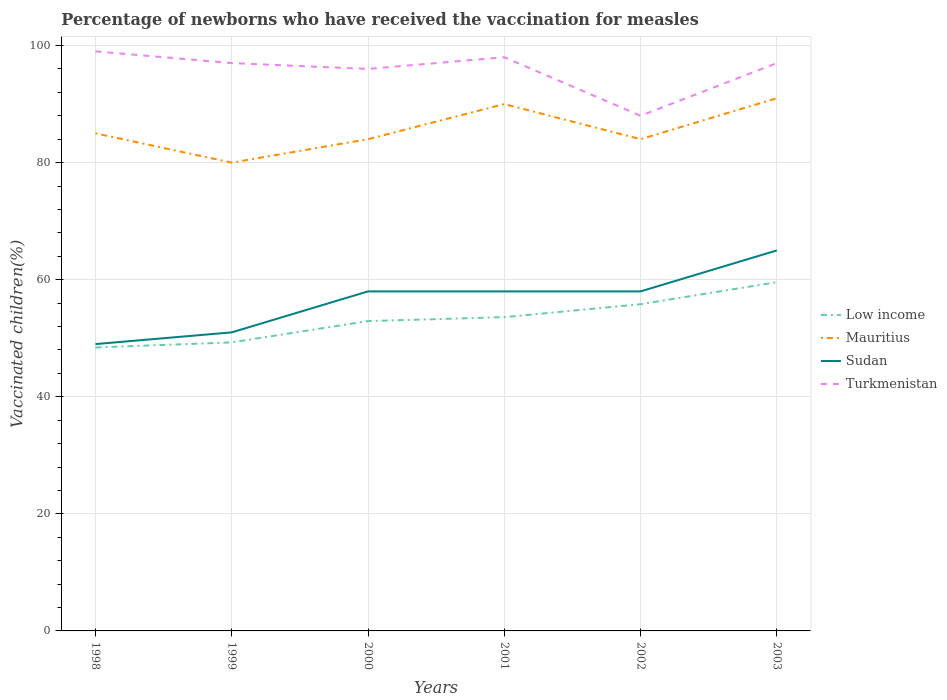Does the line corresponding to Low income intersect with the line corresponding to Mauritius?
Offer a terse response. No. Is the number of lines equal to the number of legend labels?
Provide a short and direct response. Yes. Across all years, what is the maximum percentage of vaccinated children in Sudan?
Give a very brief answer. 49. In which year was the percentage of vaccinated children in Mauritius maximum?
Your answer should be very brief. 1999. What is the difference between the highest and the lowest percentage of vaccinated children in Mauritius?
Keep it short and to the point. 2. Is the percentage of vaccinated children in Low income strictly greater than the percentage of vaccinated children in Mauritius over the years?
Make the answer very short. Yes. How many years are there in the graph?
Offer a very short reply. 6. Are the values on the major ticks of Y-axis written in scientific E-notation?
Ensure brevity in your answer.  No. Does the graph contain any zero values?
Provide a succinct answer. No. Does the graph contain grids?
Make the answer very short. Yes. What is the title of the graph?
Ensure brevity in your answer.  Percentage of newborns who have received the vaccination for measles. Does "Iran" appear as one of the legend labels in the graph?
Ensure brevity in your answer.  No. What is the label or title of the X-axis?
Ensure brevity in your answer.  Years. What is the label or title of the Y-axis?
Keep it short and to the point. Vaccinated children(%). What is the Vaccinated children(%) in Low income in 1998?
Ensure brevity in your answer.  48.42. What is the Vaccinated children(%) in Sudan in 1998?
Ensure brevity in your answer.  49. What is the Vaccinated children(%) in Turkmenistan in 1998?
Offer a terse response. 99. What is the Vaccinated children(%) of Low income in 1999?
Ensure brevity in your answer.  49.29. What is the Vaccinated children(%) of Sudan in 1999?
Offer a terse response. 51. What is the Vaccinated children(%) of Turkmenistan in 1999?
Keep it short and to the point. 97. What is the Vaccinated children(%) of Low income in 2000?
Offer a terse response. 52.93. What is the Vaccinated children(%) of Sudan in 2000?
Offer a terse response. 58. What is the Vaccinated children(%) in Turkmenistan in 2000?
Ensure brevity in your answer.  96. What is the Vaccinated children(%) in Low income in 2001?
Your answer should be very brief. 53.6. What is the Vaccinated children(%) in Mauritius in 2001?
Your answer should be compact. 90. What is the Vaccinated children(%) in Turkmenistan in 2001?
Your response must be concise. 98. What is the Vaccinated children(%) of Low income in 2002?
Your response must be concise. 55.81. What is the Vaccinated children(%) in Turkmenistan in 2002?
Make the answer very short. 88. What is the Vaccinated children(%) in Low income in 2003?
Provide a short and direct response. 59.57. What is the Vaccinated children(%) of Mauritius in 2003?
Offer a very short reply. 91. What is the Vaccinated children(%) in Sudan in 2003?
Your response must be concise. 65. What is the Vaccinated children(%) in Turkmenistan in 2003?
Your answer should be compact. 97. Across all years, what is the maximum Vaccinated children(%) of Low income?
Give a very brief answer. 59.57. Across all years, what is the maximum Vaccinated children(%) in Mauritius?
Ensure brevity in your answer.  91. Across all years, what is the maximum Vaccinated children(%) in Sudan?
Give a very brief answer. 65. Across all years, what is the minimum Vaccinated children(%) of Low income?
Your answer should be compact. 48.42. Across all years, what is the minimum Vaccinated children(%) in Sudan?
Make the answer very short. 49. What is the total Vaccinated children(%) in Low income in the graph?
Your response must be concise. 319.62. What is the total Vaccinated children(%) of Mauritius in the graph?
Your answer should be very brief. 514. What is the total Vaccinated children(%) of Sudan in the graph?
Provide a succinct answer. 339. What is the total Vaccinated children(%) of Turkmenistan in the graph?
Make the answer very short. 575. What is the difference between the Vaccinated children(%) of Low income in 1998 and that in 1999?
Make the answer very short. -0.87. What is the difference between the Vaccinated children(%) in Turkmenistan in 1998 and that in 1999?
Give a very brief answer. 2. What is the difference between the Vaccinated children(%) of Low income in 1998 and that in 2000?
Give a very brief answer. -4.51. What is the difference between the Vaccinated children(%) in Sudan in 1998 and that in 2000?
Your response must be concise. -9. What is the difference between the Vaccinated children(%) in Low income in 1998 and that in 2001?
Offer a very short reply. -5.18. What is the difference between the Vaccinated children(%) of Mauritius in 1998 and that in 2001?
Keep it short and to the point. -5. What is the difference between the Vaccinated children(%) in Sudan in 1998 and that in 2001?
Ensure brevity in your answer.  -9. What is the difference between the Vaccinated children(%) of Turkmenistan in 1998 and that in 2001?
Your answer should be compact. 1. What is the difference between the Vaccinated children(%) of Low income in 1998 and that in 2002?
Offer a terse response. -7.39. What is the difference between the Vaccinated children(%) in Sudan in 1998 and that in 2002?
Your answer should be compact. -9. What is the difference between the Vaccinated children(%) in Turkmenistan in 1998 and that in 2002?
Keep it short and to the point. 11. What is the difference between the Vaccinated children(%) of Low income in 1998 and that in 2003?
Give a very brief answer. -11.15. What is the difference between the Vaccinated children(%) of Sudan in 1998 and that in 2003?
Make the answer very short. -16. What is the difference between the Vaccinated children(%) of Low income in 1999 and that in 2000?
Keep it short and to the point. -3.63. What is the difference between the Vaccinated children(%) of Turkmenistan in 1999 and that in 2000?
Your answer should be very brief. 1. What is the difference between the Vaccinated children(%) in Low income in 1999 and that in 2001?
Your response must be concise. -4.31. What is the difference between the Vaccinated children(%) in Low income in 1999 and that in 2002?
Offer a very short reply. -6.52. What is the difference between the Vaccinated children(%) in Mauritius in 1999 and that in 2002?
Your answer should be very brief. -4. What is the difference between the Vaccinated children(%) of Turkmenistan in 1999 and that in 2002?
Your response must be concise. 9. What is the difference between the Vaccinated children(%) in Low income in 1999 and that in 2003?
Give a very brief answer. -10.28. What is the difference between the Vaccinated children(%) of Turkmenistan in 1999 and that in 2003?
Provide a short and direct response. 0. What is the difference between the Vaccinated children(%) of Low income in 2000 and that in 2001?
Offer a very short reply. -0.68. What is the difference between the Vaccinated children(%) in Mauritius in 2000 and that in 2001?
Make the answer very short. -6. What is the difference between the Vaccinated children(%) in Low income in 2000 and that in 2002?
Provide a succinct answer. -2.88. What is the difference between the Vaccinated children(%) of Mauritius in 2000 and that in 2002?
Keep it short and to the point. 0. What is the difference between the Vaccinated children(%) in Low income in 2000 and that in 2003?
Keep it short and to the point. -6.65. What is the difference between the Vaccinated children(%) in Sudan in 2000 and that in 2003?
Make the answer very short. -7. What is the difference between the Vaccinated children(%) of Low income in 2001 and that in 2002?
Your answer should be compact. -2.21. What is the difference between the Vaccinated children(%) of Mauritius in 2001 and that in 2002?
Offer a very short reply. 6. What is the difference between the Vaccinated children(%) of Turkmenistan in 2001 and that in 2002?
Offer a very short reply. 10. What is the difference between the Vaccinated children(%) in Low income in 2001 and that in 2003?
Make the answer very short. -5.97. What is the difference between the Vaccinated children(%) in Sudan in 2001 and that in 2003?
Give a very brief answer. -7. What is the difference between the Vaccinated children(%) of Turkmenistan in 2001 and that in 2003?
Provide a short and direct response. 1. What is the difference between the Vaccinated children(%) of Low income in 2002 and that in 2003?
Provide a short and direct response. -3.76. What is the difference between the Vaccinated children(%) in Mauritius in 2002 and that in 2003?
Keep it short and to the point. -7. What is the difference between the Vaccinated children(%) in Low income in 1998 and the Vaccinated children(%) in Mauritius in 1999?
Provide a short and direct response. -31.58. What is the difference between the Vaccinated children(%) of Low income in 1998 and the Vaccinated children(%) of Sudan in 1999?
Offer a very short reply. -2.58. What is the difference between the Vaccinated children(%) of Low income in 1998 and the Vaccinated children(%) of Turkmenistan in 1999?
Your answer should be very brief. -48.58. What is the difference between the Vaccinated children(%) in Mauritius in 1998 and the Vaccinated children(%) in Sudan in 1999?
Offer a terse response. 34. What is the difference between the Vaccinated children(%) in Mauritius in 1998 and the Vaccinated children(%) in Turkmenistan in 1999?
Provide a succinct answer. -12. What is the difference between the Vaccinated children(%) of Sudan in 1998 and the Vaccinated children(%) of Turkmenistan in 1999?
Offer a very short reply. -48. What is the difference between the Vaccinated children(%) in Low income in 1998 and the Vaccinated children(%) in Mauritius in 2000?
Offer a terse response. -35.58. What is the difference between the Vaccinated children(%) of Low income in 1998 and the Vaccinated children(%) of Sudan in 2000?
Your answer should be very brief. -9.58. What is the difference between the Vaccinated children(%) in Low income in 1998 and the Vaccinated children(%) in Turkmenistan in 2000?
Your answer should be compact. -47.58. What is the difference between the Vaccinated children(%) in Sudan in 1998 and the Vaccinated children(%) in Turkmenistan in 2000?
Ensure brevity in your answer.  -47. What is the difference between the Vaccinated children(%) of Low income in 1998 and the Vaccinated children(%) of Mauritius in 2001?
Ensure brevity in your answer.  -41.58. What is the difference between the Vaccinated children(%) of Low income in 1998 and the Vaccinated children(%) of Sudan in 2001?
Make the answer very short. -9.58. What is the difference between the Vaccinated children(%) in Low income in 1998 and the Vaccinated children(%) in Turkmenistan in 2001?
Your answer should be very brief. -49.58. What is the difference between the Vaccinated children(%) in Mauritius in 1998 and the Vaccinated children(%) in Turkmenistan in 2001?
Offer a very short reply. -13. What is the difference between the Vaccinated children(%) of Sudan in 1998 and the Vaccinated children(%) of Turkmenistan in 2001?
Your response must be concise. -49. What is the difference between the Vaccinated children(%) in Low income in 1998 and the Vaccinated children(%) in Mauritius in 2002?
Offer a terse response. -35.58. What is the difference between the Vaccinated children(%) in Low income in 1998 and the Vaccinated children(%) in Sudan in 2002?
Offer a very short reply. -9.58. What is the difference between the Vaccinated children(%) of Low income in 1998 and the Vaccinated children(%) of Turkmenistan in 2002?
Give a very brief answer. -39.58. What is the difference between the Vaccinated children(%) in Sudan in 1998 and the Vaccinated children(%) in Turkmenistan in 2002?
Your answer should be compact. -39. What is the difference between the Vaccinated children(%) in Low income in 1998 and the Vaccinated children(%) in Mauritius in 2003?
Your answer should be compact. -42.58. What is the difference between the Vaccinated children(%) of Low income in 1998 and the Vaccinated children(%) of Sudan in 2003?
Keep it short and to the point. -16.58. What is the difference between the Vaccinated children(%) in Low income in 1998 and the Vaccinated children(%) in Turkmenistan in 2003?
Provide a succinct answer. -48.58. What is the difference between the Vaccinated children(%) in Sudan in 1998 and the Vaccinated children(%) in Turkmenistan in 2003?
Your answer should be compact. -48. What is the difference between the Vaccinated children(%) of Low income in 1999 and the Vaccinated children(%) of Mauritius in 2000?
Offer a terse response. -34.71. What is the difference between the Vaccinated children(%) of Low income in 1999 and the Vaccinated children(%) of Sudan in 2000?
Give a very brief answer. -8.71. What is the difference between the Vaccinated children(%) in Low income in 1999 and the Vaccinated children(%) in Turkmenistan in 2000?
Ensure brevity in your answer.  -46.71. What is the difference between the Vaccinated children(%) of Mauritius in 1999 and the Vaccinated children(%) of Sudan in 2000?
Provide a short and direct response. 22. What is the difference between the Vaccinated children(%) in Mauritius in 1999 and the Vaccinated children(%) in Turkmenistan in 2000?
Give a very brief answer. -16. What is the difference between the Vaccinated children(%) of Sudan in 1999 and the Vaccinated children(%) of Turkmenistan in 2000?
Your answer should be very brief. -45. What is the difference between the Vaccinated children(%) of Low income in 1999 and the Vaccinated children(%) of Mauritius in 2001?
Ensure brevity in your answer.  -40.71. What is the difference between the Vaccinated children(%) in Low income in 1999 and the Vaccinated children(%) in Sudan in 2001?
Your answer should be very brief. -8.71. What is the difference between the Vaccinated children(%) in Low income in 1999 and the Vaccinated children(%) in Turkmenistan in 2001?
Ensure brevity in your answer.  -48.71. What is the difference between the Vaccinated children(%) in Sudan in 1999 and the Vaccinated children(%) in Turkmenistan in 2001?
Your answer should be very brief. -47. What is the difference between the Vaccinated children(%) of Low income in 1999 and the Vaccinated children(%) of Mauritius in 2002?
Make the answer very short. -34.71. What is the difference between the Vaccinated children(%) in Low income in 1999 and the Vaccinated children(%) in Sudan in 2002?
Give a very brief answer. -8.71. What is the difference between the Vaccinated children(%) in Low income in 1999 and the Vaccinated children(%) in Turkmenistan in 2002?
Provide a succinct answer. -38.71. What is the difference between the Vaccinated children(%) in Mauritius in 1999 and the Vaccinated children(%) in Sudan in 2002?
Your answer should be very brief. 22. What is the difference between the Vaccinated children(%) of Sudan in 1999 and the Vaccinated children(%) of Turkmenistan in 2002?
Offer a terse response. -37. What is the difference between the Vaccinated children(%) of Low income in 1999 and the Vaccinated children(%) of Mauritius in 2003?
Offer a terse response. -41.71. What is the difference between the Vaccinated children(%) in Low income in 1999 and the Vaccinated children(%) in Sudan in 2003?
Provide a succinct answer. -15.71. What is the difference between the Vaccinated children(%) of Low income in 1999 and the Vaccinated children(%) of Turkmenistan in 2003?
Provide a succinct answer. -47.71. What is the difference between the Vaccinated children(%) in Mauritius in 1999 and the Vaccinated children(%) in Turkmenistan in 2003?
Make the answer very short. -17. What is the difference between the Vaccinated children(%) of Sudan in 1999 and the Vaccinated children(%) of Turkmenistan in 2003?
Provide a short and direct response. -46. What is the difference between the Vaccinated children(%) in Low income in 2000 and the Vaccinated children(%) in Mauritius in 2001?
Give a very brief answer. -37.07. What is the difference between the Vaccinated children(%) of Low income in 2000 and the Vaccinated children(%) of Sudan in 2001?
Make the answer very short. -5.07. What is the difference between the Vaccinated children(%) of Low income in 2000 and the Vaccinated children(%) of Turkmenistan in 2001?
Offer a terse response. -45.07. What is the difference between the Vaccinated children(%) of Mauritius in 2000 and the Vaccinated children(%) of Sudan in 2001?
Your response must be concise. 26. What is the difference between the Vaccinated children(%) in Mauritius in 2000 and the Vaccinated children(%) in Turkmenistan in 2001?
Make the answer very short. -14. What is the difference between the Vaccinated children(%) of Low income in 2000 and the Vaccinated children(%) of Mauritius in 2002?
Offer a very short reply. -31.07. What is the difference between the Vaccinated children(%) in Low income in 2000 and the Vaccinated children(%) in Sudan in 2002?
Keep it short and to the point. -5.07. What is the difference between the Vaccinated children(%) of Low income in 2000 and the Vaccinated children(%) of Turkmenistan in 2002?
Ensure brevity in your answer.  -35.07. What is the difference between the Vaccinated children(%) of Mauritius in 2000 and the Vaccinated children(%) of Sudan in 2002?
Ensure brevity in your answer.  26. What is the difference between the Vaccinated children(%) in Low income in 2000 and the Vaccinated children(%) in Mauritius in 2003?
Provide a short and direct response. -38.07. What is the difference between the Vaccinated children(%) in Low income in 2000 and the Vaccinated children(%) in Sudan in 2003?
Provide a short and direct response. -12.07. What is the difference between the Vaccinated children(%) in Low income in 2000 and the Vaccinated children(%) in Turkmenistan in 2003?
Keep it short and to the point. -44.07. What is the difference between the Vaccinated children(%) of Mauritius in 2000 and the Vaccinated children(%) of Sudan in 2003?
Ensure brevity in your answer.  19. What is the difference between the Vaccinated children(%) in Sudan in 2000 and the Vaccinated children(%) in Turkmenistan in 2003?
Keep it short and to the point. -39. What is the difference between the Vaccinated children(%) in Low income in 2001 and the Vaccinated children(%) in Mauritius in 2002?
Keep it short and to the point. -30.4. What is the difference between the Vaccinated children(%) of Low income in 2001 and the Vaccinated children(%) of Sudan in 2002?
Offer a terse response. -4.4. What is the difference between the Vaccinated children(%) of Low income in 2001 and the Vaccinated children(%) of Turkmenistan in 2002?
Offer a very short reply. -34.4. What is the difference between the Vaccinated children(%) in Mauritius in 2001 and the Vaccinated children(%) in Turkmenistan in 2002?
Give a very brief answer. 2. What is the difference between the Vaccinated children(%) in Sudan in 2001 and the Vaccinated children(%) in Turkmenistan in 2002?
Keep it short and to the point. -30. What is the difference between the Vaccinated children(%) in Low income in 2001 and the Vaccinated children(%) in Mauritius in 2003?
Make the answer very short. -37.4. What is the difference between the Vaccinated children(%) in Low income in 2001 and the Vaccinated children(%) in Sudan in 2003?
Provide a short and direct response. -11.4. What is the difference between the Vaccinated children(%) in Low income in 2001 and the Vaccinated children(%) in Turkmenistan in 2003?
Your answer should be compact. -43.4. What is the difference between the Vaccinated children(%) of Mauritius in 2001 and the Vaccinated children(%) of Sudan in 2003?
Ensure brevity in your answer.  25. What is the difference between the Vaccinated children(%) of Sudan in 2001 and the Vaccinated children(%) of Turkmenistan in 2003?
Make the answer very short. -39. What is the difference between the Vaccinated children(%) in Low income in 2002 and the Vaccinated children(%) in Mauritius in 2003?
Keep it short and to the point. -35.19. What is the difference between the Vaccinated children(%) of Low income in 2002 and the Vaccinated children(%) of Sudan in 2003?
Offer a terse response. -9.19. What is the difference between the Vaccinated children(%) of Low income in 2002 and the Vaccinated children(%) of Turkmenistan in 2003?
Offer a terse response. -41.19. What is the difference between the Vaccinated children(%) in Mauritius in 2002 and the Vaccinated children(%) in Sudan in 2003?
Your response must be concise. 19. What is the difference between the Vaccinated children(%) in Mauritius in 2002 and the Vaccinated children(%) in Turkmenistan in 2003?
Your answer should be very brief. -13. What is the difference between the Vaccinated children(%) of Sudan in 2002 and the Vaccinated children(%) of Turkmenistan in 2003?
Your answer should be very brief. -39. What is the average Vaccinated children(%) of Low income per year?
Offer a very short reply. 53.27. What is the average Vaccinated children(%) in Mauritius per year?
Give a very brief answer. 85.67. What is the average Vaccinated children(%) of Sudan per year?
Provide a succinct answer. 56.5. What is the average Vaccinated children(%) of Turkmenistan per year?
Give a very brief answer. 95.83. In the year 1998, what is the difference between the Vaccinated children(%) in Low income and Vaccinated children(%) in Mauritius?
Give a very brief answer. -36.58. In the year 1998, what is the difference between the Vaccinated children(%) of Low income and Vaccinated children(%) of Sudan?
Offer a terse response. -0.58. In the year 1998, what is the difference between the Vaccinated children(%) in Low income and Vaccinated children(%) in Turkmenistan?
Offer a very short reply. -50.58. In the year 1998, what is the difference between the Vaccinated children(%) of Mauritius and Vaccinated children(%) of Sudan?
Make the answer very short. 36. In the year 1998, what is the difference between the Vaccinated children(%) of Mauritius and Vaccinated children(%) of Turkmenistan?
Your answer should be compact. -14. In the year 1998, what is the difference between the Vaccinated children(%) in Sudan and Vaccinated children(%) in Turkmenistan?
Ensure brevity in your answer.  -50. In the year 1999, what is the difference between the Vaccinated children(%) in Low income and Vaccinated children(%) in Mauritius?
Your answer should be very brief. -30.71. In the year 1999, what is the difference between the Vaccinated children(%) of Low income and Vaccinated children(%) of Sudan?
Your answer should be compact. -1.71. In the year 1999, what is the difference between the Vaccinated children(%) of Low income and Vaccinated children(%) of Turkmenistan?
Keep it short and to the point. -47.71. In the year 1999, what is the difference between the Vaccinated children(%) in Mauritius and Vaccinated children(%) in Turkmenistan?
Ensure brevity in your answer.  -17. In the year 1999, what is the difference between the Vaccinated children(%) of Sudan and Vaccinated children(%) of Turkmenistan?
Offer a terse response. -46. In the year 2000, what is the difference between the Vaccinated children(%) of Low income and Vaccinated children(%) of Mauritius?
Make the answer very short. -31.07. In the year 2000, what is the difference between the Vaccinated children(%) of Low income and Vaccinated children(%) of Sudan?
Provide a short and direct response. -5.07. In the year 2000, what is the difference between the Vaccinated children(%) of Low income and Vaccinated children(%) of Turkmenistan?
Ensure brevity in your answer.  -43.07. In the year 2000, what is the difference between the Vaccinated children(%) of Mauritius and Vaccinated children(%) of Turkmenistan?
Your answer should be compact. -12. In the year 2000, what is the difference between the Vaccinated children(%) in Sudan and Vaccinated children(%) in Turkmenistan?
Offer a very short reply. -38. In the year 2001, what is the difference between the Vaccinated children(%) of Low income and Vaccinated children(%) of Mauritius?
Your response must be concise. -36.4. In the year 2001, what is the difference between the Vaccinated children(%) of Low income and Vaccinated children(%) of Sudan?
Offer a very short reply. -4.4. In the year 2001, what is the difference between the Vaccinated children(%) of Low income and Vaccinated children(%) of Turkmenistan?
Provide a short and direct response. -44.4. In the year 2001, what is the difference between the Vaccinated children(%) in Mauritius and Vaccinated children(%) in Sudan?
Your response must be concise. 32. In the year 2001, what is the difference between the Vaccinated children(%) in Mauritius and Vaccinated children(%) in Turkmenistan?
Provide a succinct answer. -8. In the year 2002, what is the difference between the Vaccinated children(%) of Low income and Vaccinated children(%) of Mauritius?
Keep it short and to the point. -28.19. In the year 2002, what is the difference between the Vaccinated children(%) of Low income and Vaccinated children(%) of Sudan?
Keep it short and to the point. -2.19. In the year 2002, what is the difference between the Vaccinated children(%) in Low income and Vaccinated children(%) in Turkmenistan?
Ensure brevity in your answer.  -32.19. In the year 2002, what is the difference between the Vaccinated children(%) of Mauritius and Vaccinated children(%) of Sudan?
Make the answer very short. 26. In the year 2002, what is the difference between the Vaccinated children(%) of Mauritius and Vaccinated children(%) of Turkmenistan?
Keep it short and to the point. -4. In the year 2003, what is the difference between the Vaccinated children(%) in Low income and Vaccinated children(%) in Mauritius?
Give a very brief answer. -31.43. In the year 2003, what is the difference between the Vaccinated children(%) of Low income and Vaccinated children(%) of Sudan?
Ensure brevity in your answer.  -5.43. In the year 2003, what is the difference between the Vaccinated children(%) of Low income and Vaccinated children(%) of Turkmenistan?
Provide a succinct answer. -37.43. In the year 2003, what is the difference between the Vaccinated children(%) of Mauritius and Vaccinated children(%) of Sudan?
Give a very brief answer. 26. In the year 2003, what is the difference between the Vaccinated children(%) in Mauritius and Vaccinated children(%) in Turkmenistan?
Offer a very short reply. -6. In the year 2003, what is the difference between the Vaccinated children(%) of Sudan and Vaccinated children(%) of Turkmenistan?
Offer a terse response. -32. What is the ratio of the Vaccinated children(%) of Low income in 1998 to that in 1999?
Ensure brevity in your answer.  0.98. What is the ratio of the Vaccinated children(%) of Sudan in 1998 to that in 1999?
Your response must be concise. 0.96. What is the ratio of the Vaccinated children(%) of Turkmenistan in 1998 to that in 1999?
Your answer should be very brief. 1.02. What is the ratio of the Vaccinated children(%) of Low income in 1998 to that in 2000?
Your answer should be very brief. 0.91. What is the ratio of the Vaccinated children(%) of Mauritius in 1998 to that in 2000?
Provide a succinct answer. 1.01. What is the ratio of the Vaccinated children(%) in Sudan in 1998 to that in 2000?
Provide a succinct answer. 0.84. What is the ratio of the Vaccinated children(%) of Turkmenistan in 1998 to that in 2000?
Your answer should be compact. 1.03. What is the ratio of the Vaccinated children(%) of Low income in 1998 to that in 2001?
Give a very brief answer. 0.9. What is the ratio of the Vaccinated children(%) of Mauritius in 1998 to that in 2001?
Offer a terse response. 0.94. What is the ratio of the Vaccinated children(%) of Sudan in 1998 to that in 2001?
Ensure brevity in your answer.  0.84. What is the ratio of the Vaccinated children(%) in Turkmenistan in 1998 to that in 2001?
Provide a succinct answer. 1.01. What is the ratio of the Vaccinated children(%) in Low income in 1998 to that in 2002?
Your answer should be compact. 0.87. What is the ratio of the Vaccinated children(%) in Mauritius in 1998 to that in 2002?
Offer a very short reply. 1.01. What is the ratio of the Vaccinated children(%) of Sudan in 1998 to that in 2002?
Your answer should be compact. 0.84. What is the ratio of the Vaccinated children(%) in Turkmenistan in 1998 to that in 2002?
Make the answer very short. 1.12. What is the ratio of the Vaccinated children(%) in Low income in 1998 to that in 2003?
Offer a very short reply. 0.81. What is the ratio of the Vaccinated children(%) of Mauritius in 1998 to that in 2003?
Provide a short and direct response. 0.93. What is the ratio of the Vaccinated children(%) of Sudan in 1998 to that in 2003?
Your response must be concise. 0.75. What is the ratio of the Vaccinated children(%) in Turkmenistan in 1998 to that in 2003?
Your response must be concise. 1.02. What is the ratio of the Vaccinated children(%) of Low income in 1999 to that in 2000?
Ensure brevity in your answer.  0.93. What is the ratio of the Vaccinated children(%) of Sudan in 1999 to that in 2000?
Your answer should be very brief. 0.88. What is the ratio of the Vaccinated children(%) in Turkmenistan in 1999 to that in 2000?
Your answer should be very brief. 1.01. What is the ratio of the Vaccinated children(%) in Low income in 1999 to that in 2001?
Give a very brief answer. 0.92. What is the ratio of the Vaccinated children(%) in Mauritius in 1999 to that in 2001?
Offer a very short reply. 0.89. What is the ratio of the Vaccinated children(%) of Sudan in 1999 to that in 2001?
Offer a terse response. 0.88. What is the ratio of the Vaccinated children(%) in Low income in 1999 to that in 2002?
Give a very brief answer. 0.88. What is the ratio of the Vaccinated children(%) of Sudan in 1999 to that in 2002?
Offer a terse response. 0.88. What is the ratio of the Vaccinated children(%) in Turkmenistan in 1999 to that in 2002?
Your answer should be very brief. 1.1. What is the ratio of the Vaccinated children(%) in Low income in 1999 to that in 2003?
Give a very brief answer. 0.83. What is the ratio of the Vaccinated children(%) of Mauritius in 1999 to that in 2003?
Provide a short and direct response. 0.88. What is the ratio of the Vaccinated children(%) of Sudan in 1999 to that in 2003?
Your response must be concise. 0.78. What is the ratio of the Vaccinated children(%) in Low income in 2000 to that in 2001?
Your response must be concise. 0.99. What is the ratio of the Vaccinated children(%) in Sudan in 2000 to that in 2001?
Offer a terse response. 1. What is the ratio of the Vaccinated children(%) of Turkmenistan in 2000 to that in 2001?
Ensure brevity in your answer.  0.98. What is the ratio of the Vaccinated children(%) of Low income in 2000 to that in 2002?
Your answer should be compact. 0.95. What is the ratio of the Vaccinated children(%) in Low income in 2000 to that in 2003?
Your answer should be very brief. 0.89. What is the ratio of the Vaccinated children(%) of Sudan in 2000 to that in 2003?
Offer a very short reply. 0.89. What is the ratio of the Vaccinated children(%) in Turkmenistan in 2000 to that in 2003?
Your response must be concise. 0.99. What is the ratio of the Vaccinated children(%) in Low income in 2001 to that in 2002?
Your answer should be very brief. 0.96. What is the ratio of the Vaccinated children(%) of Mauritius in 2001 to that in 2002?
Keep it short and to the point. 1.07. What is the ratio of the Vaccinated children(%) of Turkmenistan in 2001 to that in 2002?
Make the answer very short. 1.11. What is the ratio of the Vaccinated children(%) of Low income in 2001 to that in 2003?
Provide a short and direct response. 0.9. What is the ratio of the Vaccinated children(%) in Mauritius in 2001 to that in 2003?
Ensure brevity in your answer.  0.99. What is the ratio of the Vaccinated children(%) of Sudan in 2001 to that in 2003?
Provide a succinct answer. 0.89. What is the ratio of the Vaccinated children(%) in Turkmenistan in 2001 to that in 2003?
Offer a terse response. 1.01. What is the ratio of the Vaccinated children(%) in Low income in 2002 to that in 2003?
Your response must be concise. 0.94. What is the ratio of the Vaccinated children(%) in Sudan in 2002 to that in 2003?
Provide a short and direct response. 0.89. What is the ratio of the Vaccinated children(%) in Turkmenistan in 2002 to that in 2003?
Your response must be concise. 0.91. What is the difference between the highest and the second highest Vaccinated children(%) in Low income?
Make the answer very short. 3.76. What is the difference between the highest and the second highest Vaccinated children(%) in Mauritius?
Keep it short and to the point. 1. What is the difference between the highest and the lowest Vaccinated children(%) in Low income?
Your answer should be very brief. 11.15. What is the difference between the highest and the lowest Vaccinated children(%) of Mauritius?
Your answer should be compact. 11. What is the difference between the highest and the lowest Vaccinated children(%) in Sudan?
Give a very brief answer. 16. 